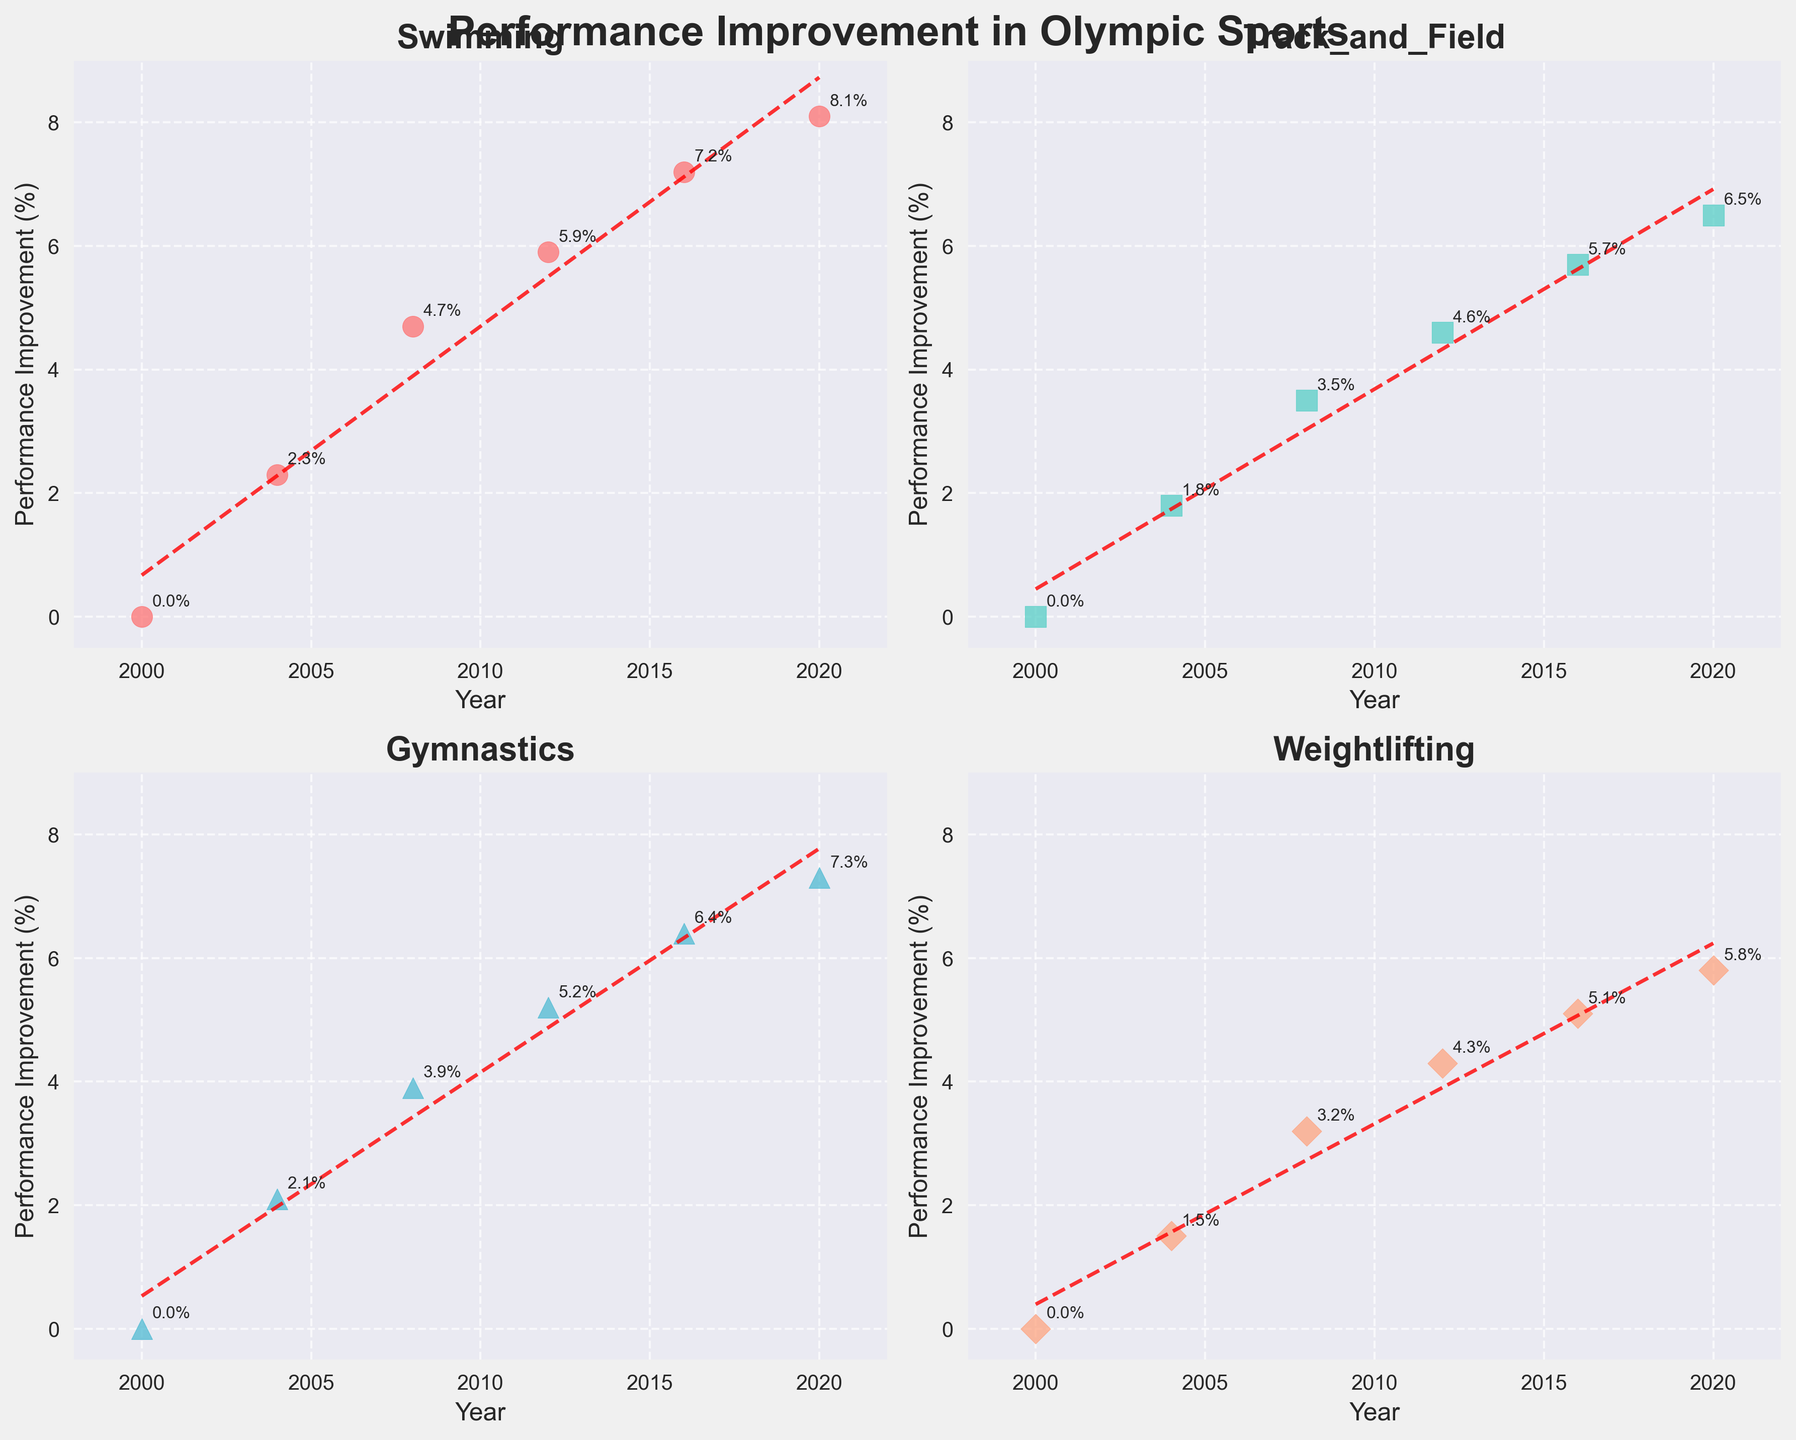What is the title of the figure? The title of the figure is often found at the top and provides an overview of what the figure is about. Looking at the top of the figure, we see the title "Performance Improvement in Olympic Sports."
Answer: Performance Improvement in Olympic Sports Which sport shows the highest performance improvement in the year 2020? By examining the data points for each subplot in the year 2020, we notice that Swimming shows the highest performance improvement with a value of 8.1%.
Answer: Swimming How many subplots are there in the figure? The figure layout is 2x2, meaning 2 rows and 2 columns, which amounts to 4 subplots. This is evident from the grid layout, which features 4 distinct plots each dedicated to a different sport.
Answer: 4 Which sport's performance improvement shows the steepest trend line? The steepest trend line can be determined by looking at the angle and the slope of the trend lines across all four subplots. Swimming's trend line appears steepest based on the visualization. This indicates a rapid increase in performance improvement over time.
Answer: Swimming What is the performance improvement of Gymnastics in 2016? We locate Gymnastics' subplot and look at the data point corresponding to the year 2016. It shows a performance improvement of 6.4%.
Answer: 6.4% Which two sports have a similar trend in performance improvement from 2004 to 2012? By comparing the trends between 2004 and 2012 across different subplots, Gymnastics and Track_and_Field show a similar pattern of steady increase. This can be observed from the visual slopes and data points during this period.
Answer: Gymnastics and Track_and_Field Is there any sport whose performance improvement decreased at any point in time? A careful examination of all data points and their trends in each subplot shows that none of the sports experienced a decrease; all trends are steadily increasing.
Answer: No Between 2000 and 2008, which sport saw the greatest increase in performance improvement? We calculate the increase for each sport between 2000 and 2008. Swimming increased from 0% to 4.7%, Track_and_Field from 0% to 3.5%, Gymnastics from 0% to 3.9%, and Weightlifting from 0% to 3.2%. Swimming shows the greatest increase with 4.7%.
Answer: Swimming What is the average performance improvement of Weightlifting across all the years provided? Adding the values for Weightlifting (0, 1.5, 3.2, 4.3, 5.1, 5.8) gives 19.9%. Dividing by the number of data points (6), the average performance improvement is 3.32%.
Answer: 3.32% In which year did Track_and_Field surpass a performance improvement of 3% for the first time? Reviewing the data for Track_and_Field subplot, performance improvement exceeds 3% in 2008 for the first time, reaching 3.5%.
Answer: 2008 